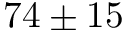Convert formula to latex. <formula><loc_0><loc_0><loc_500><loc_500>7 4 \pm 1 5</formula> 